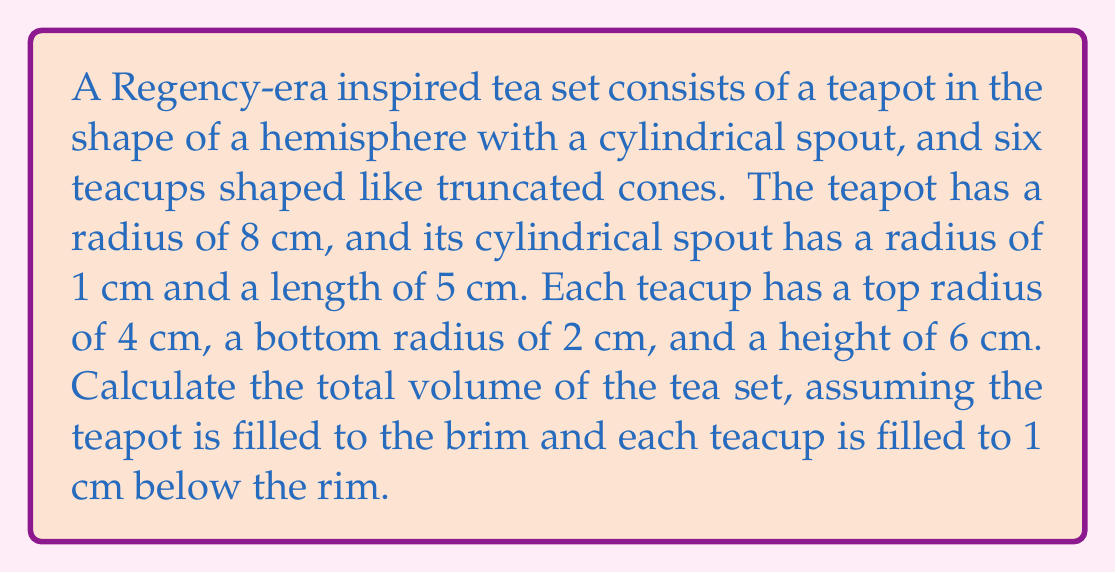Could you help me with this problem? Let's break this problem down into parts:

1. Volume of the teapot:
   a) Volume of the hemisphere: $V_h = \frac{2}{3}\pi r^3$
      $V_h = \frac{2}{3}\pi (8\text{ cm})^3 = \frac{1024}{3}\pi \text{ cm}^3$
   b) Volume of the cylindrical spout: $V_s = \pi r^2 h$
      $V_s = \pi (1\text{ cm})^2 (5\text{ cm}) = 5\pi \text{ cm}^3$
   Total teapot volume: $V_t = V_h + V_s = \frac{1024}{3}\pi \text{ cm}^3 + 5\pi \text{ cm}^3 = \frac{1039}{3}\pi \text{ cm}^3$

2. Volume of each teacup:
   The teacups are truncated cones filled to 1 cm below the rim. We need to calculate:
   a) Volume of the full truncated cone: $V_f = \frac{1}{3}\pi h(R^2 + r^2 + Rr)$
      $V_f = \frac{1}{3}\pi (6\text{ cm})((4\text{ cm})^2 + (2\text{ cm})^2 + (4\text{ cm})(2\text{ cm})) = 112\pi \text{ cm}^3$
   b) Volume of the top 1 cm (not filled): $V_t = \frac{1}{3}\pi (1\text{ cm})((4\text{ cm})^2 + (3.67\text{ cm})^2 + (4\text{ cm})(3.67\text{ cm}))$
      (Note: The radius at 1 cm down is approximately 3.67 cm)
      $V_t \approx 14.45\pi \text{ cm}^3$
   Volume of each filled teacup: $V_c = V_f - V_t \approx 97.55\pi \text{ cm}^3$

3. Total volume of the tea set:
   $V_{total} = V_t + 6V_c = \frac{1039}{3}\pi \text{ cm}^3 + 6(97.55\pi \text{ cm}^3) = \frac{1039}{3}\pi \text{ cm}^3 + 585.3\pi \text{ cm}^3$
   $V_{total} = \frac{1039 + 1755.9}{3}\pi \text{ cm}^3 = 931.63\pi \text{ cm}^3 \approx 2927.33 \text{ cm}^3$
Answer: The total volume of the Regency-era inspired tea set is approximately 2927.33 cm³. 